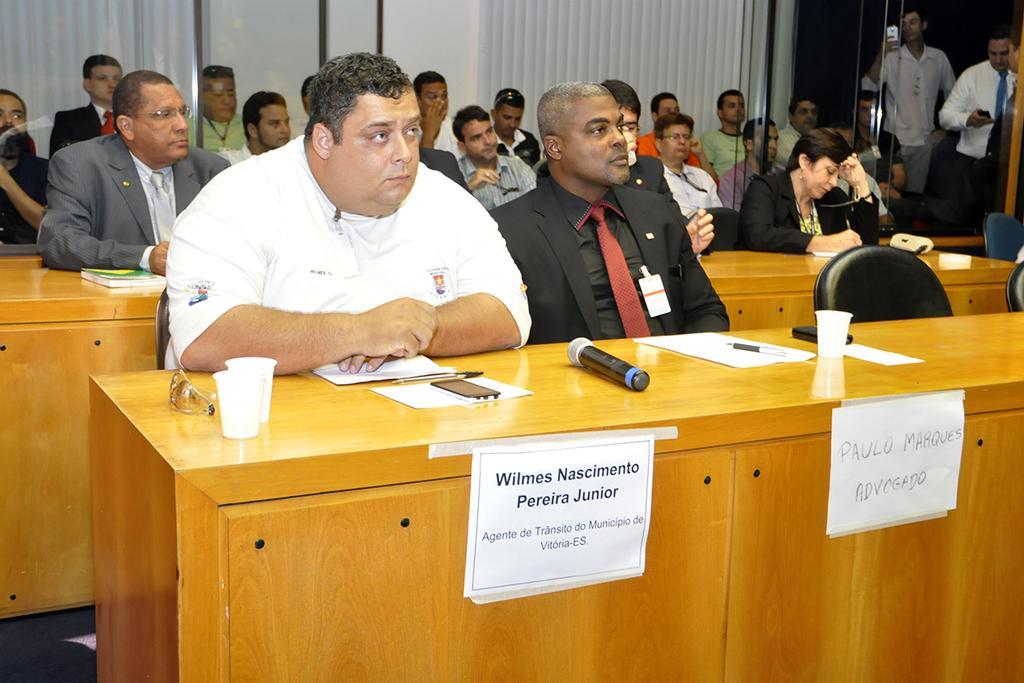Describe this image in one or two sentences. This photo is taken inside a meeting hall. We can many people are sitting. In front of them there is a desk. In the desk the nameplate is pasted. On the table we can see mic,paper, cup,glasses. In the middle one person is sitting who is wearing a white dress beside him another person ,he is wearing a black suit,red tie. On the right top corner we can see there is a door And people are standing with their phone. One person is clicking photo. 